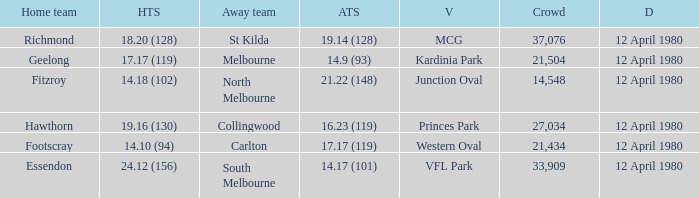Parse the full table. {'header': ['Home team', 'HTS', 'Away team', 'ATS', 'V', 'Crowd', 'D'], 'rows': [['Richmond', '18.20 (128)', 'St Kilda', '19.14 (128)', 'MCG', '37,076', '12 April 1980'], ['Geelong', '17.17 (119)', 'Melbourne', '14.9 (93)', 'Kardinia Park', '21,504', '12 April 1980'], ['Fitzroy', '14.18 (102)', 'North Melbourne', '21.22 (148)', 'Junction Oval', '14,548', '12 April 1980'], ['Hawthorn', '19.16 (130)', 'Collingwood', '16.23 (119)', 'Princes Park', '27,034', '12 April 1980'], ['Footscray', '14.10 (94)', 'Carlton', '17.17 (119)', 'Western Oval', '21,434', '12 April 1980'], ['Essendon', '24.12 (156)', 'South Melbourne', '14.17 (101)', 'VFL Park', '33,909', '12 April 1980']]} Where did Essendon play as the home team? VFL Park. 